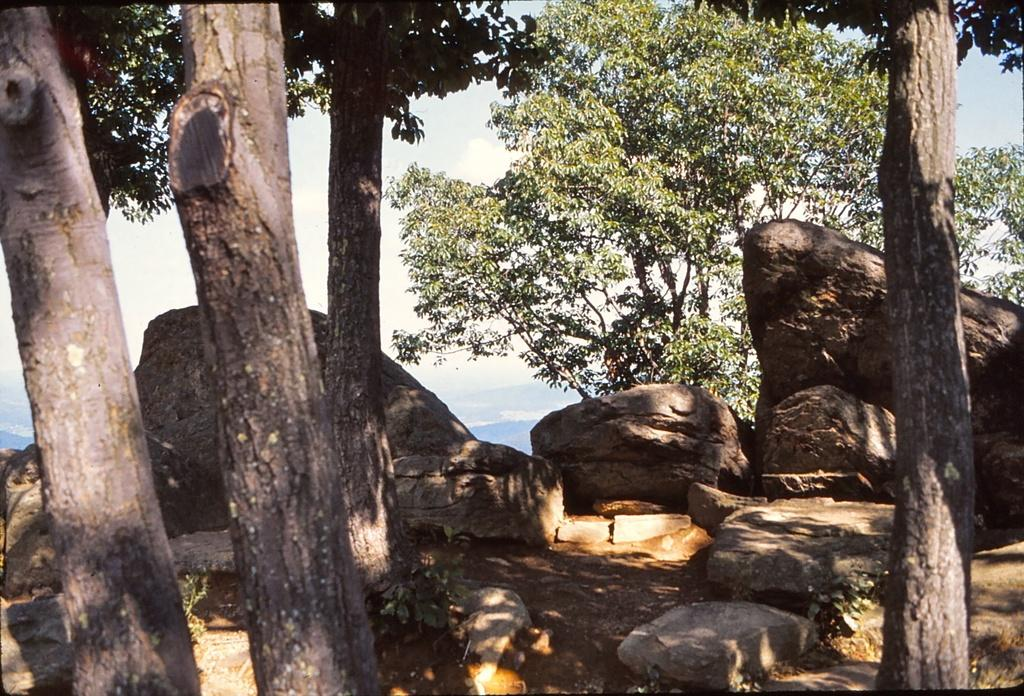What can be seen in the foreground of the image? There are trees in the foreground of the image. What is visible in the background of the image? In the background, there are rocks, sand, plants, trees, and mountains. What is the condition of the sky in the image? The sky is visible at the top of the image. How does the hose contribute to the development of the trees in the image? There is no hose present in the image, so it cannot contribute to the development of the trees. 